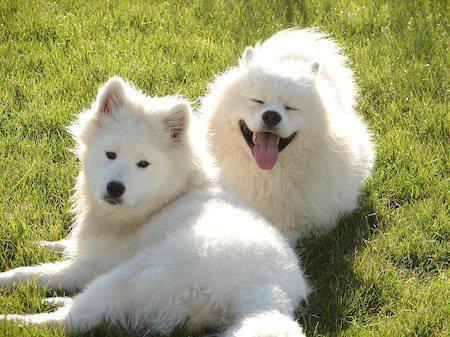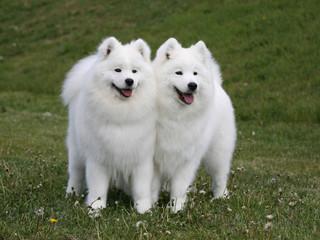The first image is the image on the left, the second image is the image on the right. Assess this claim about the two images: "One image shows two white dogs sitting upright side-by-side, and the other image shows two sitting collies flanked by two sitting white dogs.". Correct or not? Answer yes or no. No. The first image is the image on the left, the second image is the image on the right. Evaluate the accuracy of this statement regarding the images: "One of the images has two brown and white dogs in between two white dogs.". Is it true? Answer yes or no. No. 